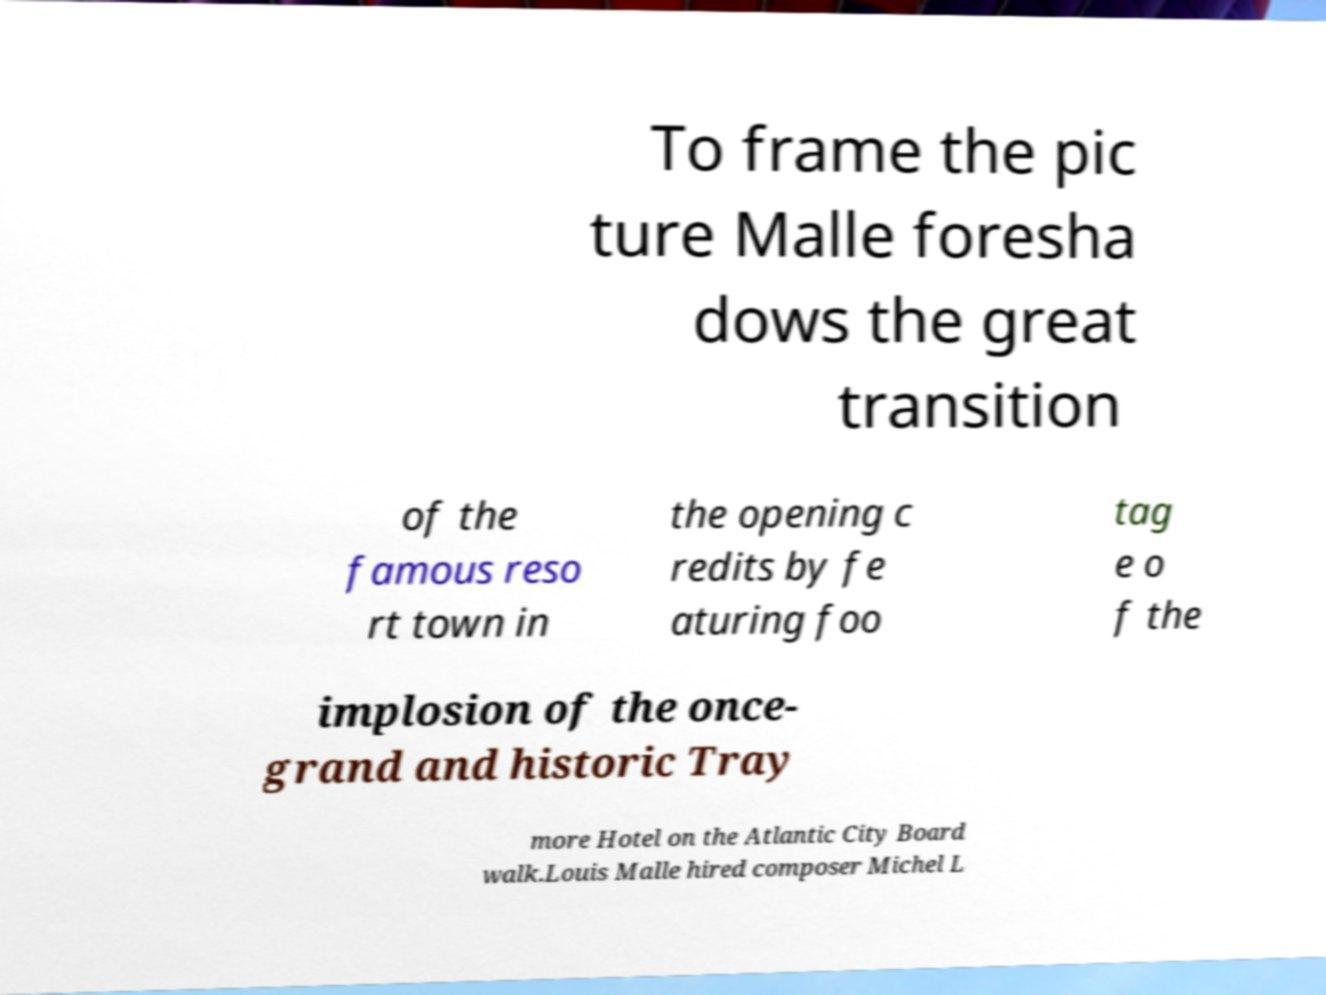Please identify and transcribe the text found in this image. To frame the pic ture Malle foresha dows the great transition of the famous reso rt town in the opening c redits by fe aturing foo tag e o f the implosion of the once- grand and historic Tray more Hotel on the Atlantic City Board walk.Louis Malle hired composer Michel L 